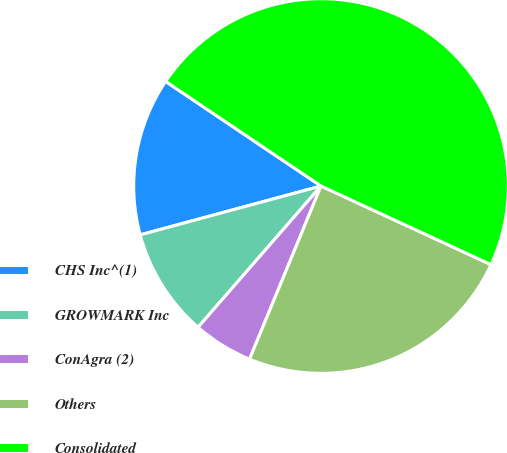Convert chart. <chart><loc_0><loc_0><loc_500><loc_500><pie_chart><fcel>CHS Inc^(1)<fcel>GROWMARK Inc<fcel>ConAgra (2)<fcel>Others<fcel>Consolidated<nl><fcel>13.63%<fcel>9.4%<fcel>5.17%<fcel>24.34%<fcel>47.47%<nl></chart> 